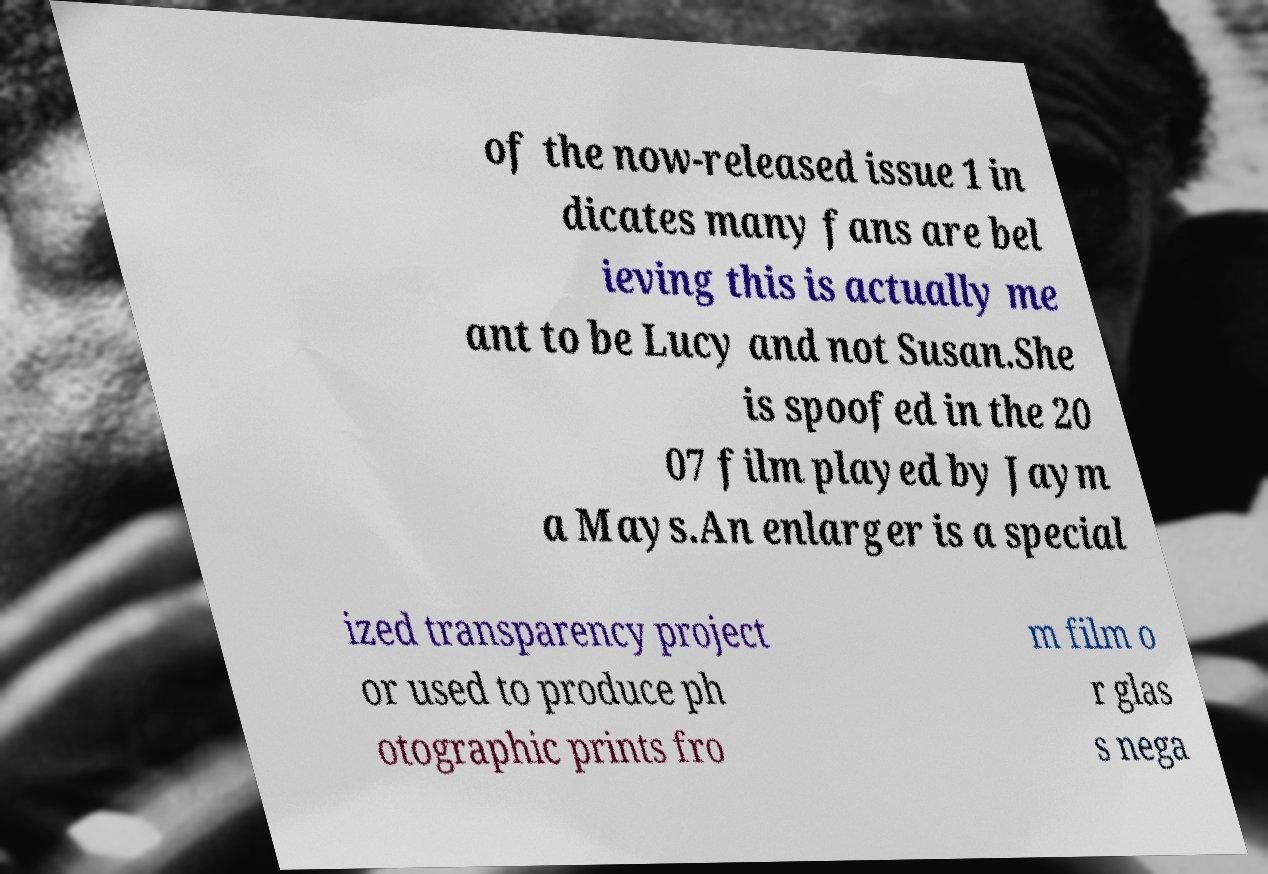For documentation purposes, I need the text within this image transcribed. Could you provide that? of the now-released issue 1 in dicates many fans are bel ieving this is actually me ant to be Lucy and not Susan.She is spoofed in the 20 07 film played by Jaym a Mays.An enlarger is a special ized transparency project or used to produce ph otographic prints fro m film o r glas s nega 